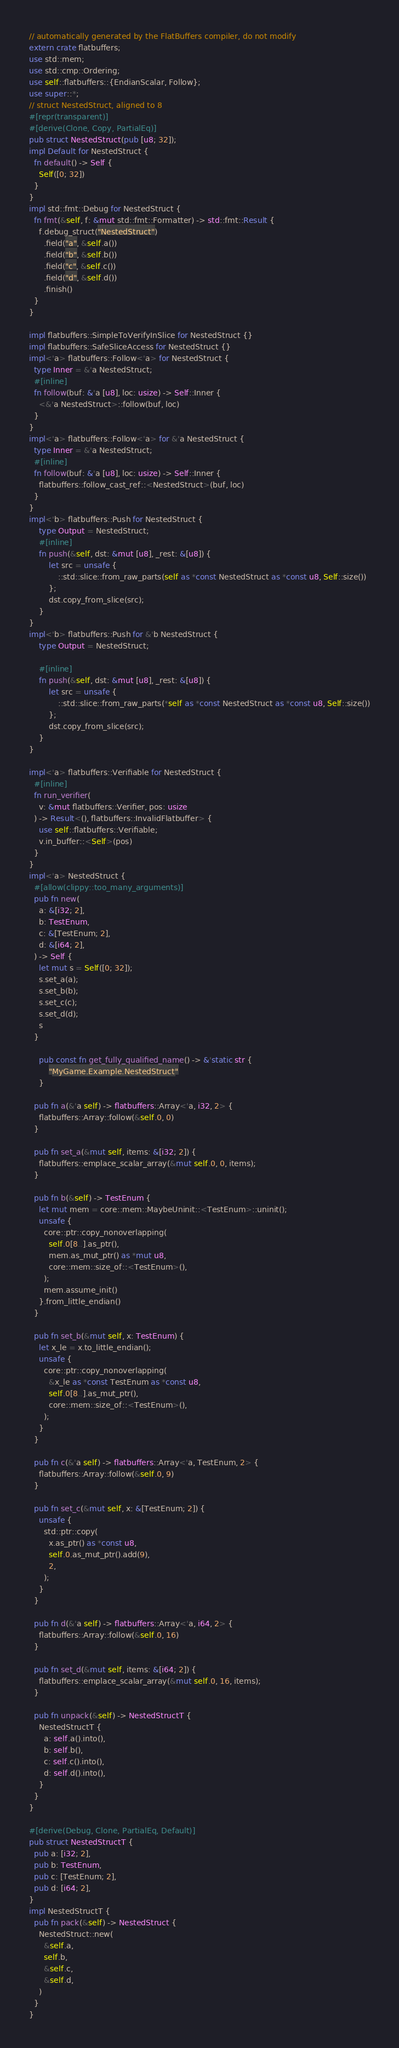Convert code to text. <code><loc_0><loc_0><loc_500><loc_500><_Rust_>// automatically generated by the FlatBuffers compiler, do not modify
extern crate flatbuffers;
use std::mem;
use std::cmp::Ordering;
use self::flatbuffers::{EndianScalar, Follow};
use super::*;
// struct NestedStruct, aligned to 8
#[repr(transparent)]
#[derive(Clone, Copy, PartialEq)]
pub struct NestedStruct(pub [u8; 32]);
impl Default for NestedStruct { 
  fn default() -> Self { 
    Self([0; 32])
  }
}
impl std::fmt::Debug for NestedStruct {
  fn fmt(&self, f: &mut std::fmt::Formatter) -> std::fmt::Result {
    f.debug_struct("NestedStruct")
      .field("a", &self.a())
      .field("b", &self.b())
      .field("c", &self.c())
      .field("d", &self.d())
      .finish()
  }
}

impl flatbuffers::SimpleToVerifyInSlice for NestedStruct {}
impl flatbuffers::SafeSliceAccess for NestedStruct {}
impl<'a> flatbuffers::Follow<'a> for NestedStruct {
  type Inner = &'a NestedStruct;
  #[inline]
  fn follow(buf: &'a [u8], loc: usize) -> Self::Inner {
    <&'a NestedStruct>::follow(buf, loc)
  }
}
impl<'a> flatbuffers::Follow<'a> for &'a NestedStruct {
  type Inner = &'a NestedStruct;
  #[inline]
  fn follow(buf: &'a [u8], loc: usize) -> Self::Inner {
    flatbuffers::follow_cast_ref::<NestedStruct>(buf, loc)
  }
}
impl<'b> flatbuffers::Push for NestedStruct {
    type Output = NestedStruct;
    #[inline]
    fn push(&self, dst: &mut [u8], _rest: &[u8]) {
        let src = unsafe {
            ::std::slice::from_raw_parts(self as *const NestedStruct as *const u8, Self::size())
        };
        dst.copy_from_slice(src);
    }
}
impl<'b> flatbuffers::Push for &'b NestedStruct {
    type Output = NestedStruct;

    #[inline]
    fn push(&self, dst: &mut [u8], _rest: &[u8]) {
        let src = unsafe {
            ::std::slice::from_raw_parts(*self as *const NestedStruct as *const u8, Self::size())
        };
        dst.copy_from_slice(src);
    }
}

impl<'a> flatbuffers::Verifiable for NestedStruct {
  #[inline]
  fn run_verifier(
    v: &mut flatbuffers::Verifier, pos: usize
  ) -> Result<(), flatbuffers::InvalidFlatbuffer> {
    use self::flatbuffers::Verifiable;
    v.in_buffer::<Self>(pos)
  }
}
impl<'a> NestedStruct {
  #[allow(clippy::too_many_arguments)]
  pub fn new(
    a: &[i32; 2],
    b: TestEnum,
    c: &[TestEnum; 2],
    d: &[i64; 2],
  ) -> Self {
    let mut s = Self([0; 32]);
    s.set_a(a);
    s.set_b(b);
    s.set_c(c);
    s.set_d(d);
    s
  }

    pub const fn get_fully_qualified_name() -> &'static str {
        "MyGame.Example.NestedStruct"
    }

  pub fn a(&'a self) -> flatbuffers::Array<'a, i32, 2> {
    flatbuffers::Array::follow(&self.0, 0)
  }

  pub fn set_a(&mut self, items: &[i32; 2]) {
    flatbuffers::emplace_scalar_array(&mut self.0, 0, items);
  }

  pub fn b(&self) -> TestEnum {
    let mut mem = core::mem::MaybeUninit::<TestEnum>::uninit();
    unsafe {
      core::ptr::copy_nonoverlapping(
        self.0[8..].as_ptr(),
        mem.as_mut_ptr() as *mut u8,
        core::mem::size_of::<TestEnum>(),
      );
      mem.assume_init()
    }.from_little_endian()
  }

  pub fn set_b(&mut self, x: TestEnum) {
    let x_le = x.to_little_endian();
    unsafe {
      core::ptr::copy_nonoverlapping(
        &x_le as *const TestEnum as *const u8,
        self.0[8..].as_mut_ptr(),
        core::mem::size_of::<TestEnum>(),
      );
    }
  }

  pub fn c(&'a self) -> flatbuffers::Array<'a, TestEnum, 2> {
    flatbuffers::Array::follow(&self.0, 9)
  }

  pub fn set_c(&mut self, x: &[TestEnum; 2]) {
    unsafe {
      std::ptr::copy(
        x.as_ptr() as *const u8,
        self.0.as_mut_ptr().add(9),
        2,
      );
    }
  }

  pub fn d(&'a self) -> flatbuffers::Array<'a, i64, 2> {
    flatbuffers::Array::follow(&self.0, 16)
  }

  pub fn set_d(&mut self, items: &[i64; 2]) {
    flatbuffers::emplace_scalar_array(&mut self.0, 16, items);
  }

  pub fn unpack(&self) -> NestedStructT {
    NestedStructT {
      a: self.a().into(),
      b: self.b(),
      c: self.c().into(),
      d: self.d().into(),
    }
  }
}

#[derive(Debug, Clone, PartialEq, Default)]
pub struct NestedStructT {
  pub a: [i32; 2],
  pub b: TestEnum,
  pub c: [TestEnum; 2],
  pub d: [i64; 2],
}
impl NestedStructT {
  pub fn pack(&self) -> NestedStruct {
    NestedStruct::new(
      &self.a,
      self.b,
      &self.c,
      &self.d,
    )
  }
}

</code> 